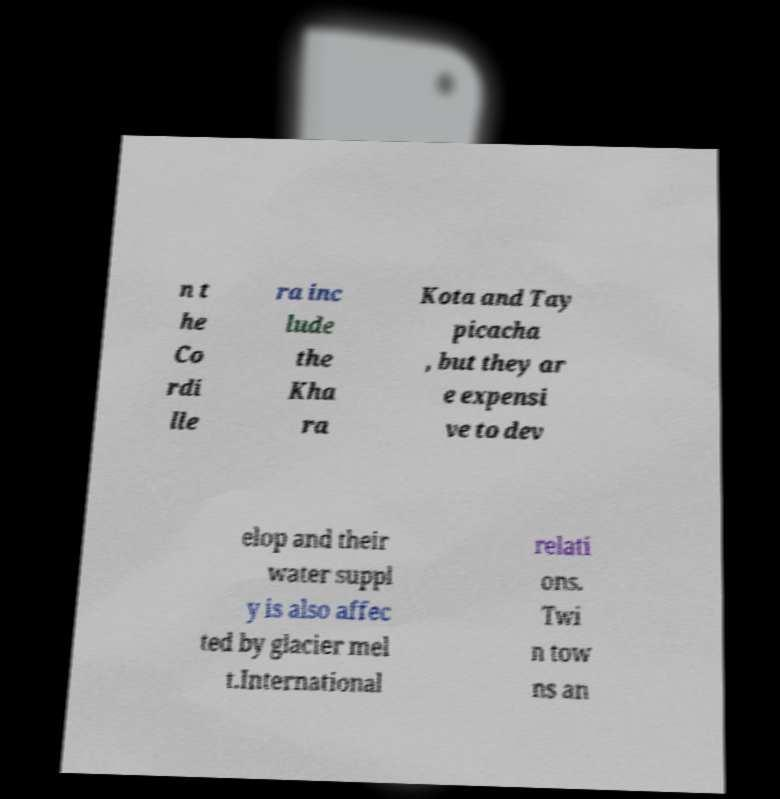Can you read and provide the text displayed in the image?This photo seems to have some interesting text. Can you extract and type it out for me? n t he Co rdi lle ra inc lude the Kha ra Kota and Tay picacha , but they ar e expensi ve to dev elop and their water suppl y is also affec ted by glacier mel t.International relati ons. Twi n tow ns an 